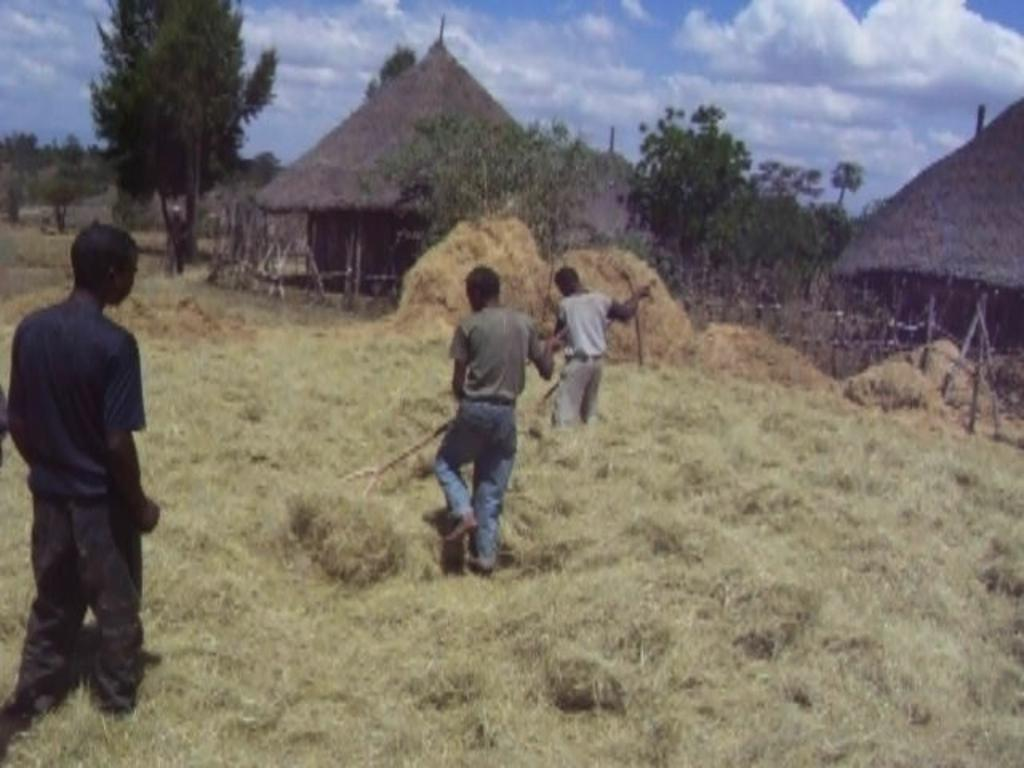How many people are in the image? There are three persons in the image. What type of vegetation is visible in the image? There is dried grass in the image. What can be seen in the background of the image? There are trees, huts, and the sky visible in the background of the image. What is the condition of the sky in the image? The sky is visible in the background of the image, and clouds are present. What type of paper is being used for the selection process in the image? There is no paper or selection process present in the image. Can you see any ants crawling on the huts in the background of the image? There are no ants visible in the image. 